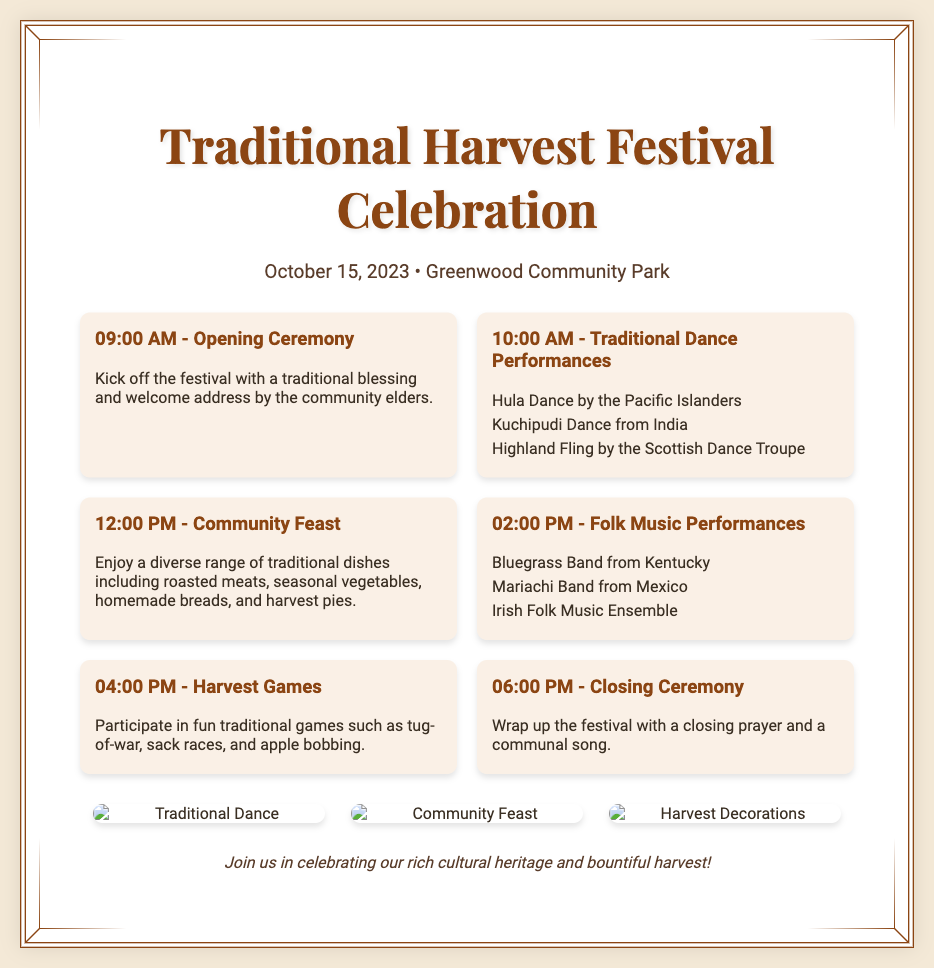What is the date of the festival? The date of the festival is mentioned in the document's date-location section, which states October 15, 2023.
Answer: October 15, 2023 What is the location of the celebration? The location is specified in the same section as the date, indicating Greenwood Community Park as the venue.
Answer: Greenwood Community Park What time does the opening ceremony start? The opening ceremony is scheduled for 09:00 AM according to the schedule of events listed in the document.
Answer: 09:00 AM How many traditional dances are performed? The schedule lists three traditional dance performances during the event, including Hula, Kuchipudi, and Highland Fling.
Answer: Three What type of food is served at the community feast? The document describes the community feast as having a diverse range of traditional dishes, explicitly mentioning roasted meats and seasonal vegetables.
Answer: Roasted meats and seasonal vegetables What is the last event of the festival? The final event is indicated in the schedule as the Closing Ceremony at 06:00 PM, wrapping up the festival activities.
Answer: Closing Ceremony What types of music are performed at the festival? The schedule includes performances by a Bluegrass Band, a Mariachi Band, and an Irish Folk Music Ensemble, showcasing a variety of musical traditions.
Answer: Bluegrass, Mariachi, Irish Folk What traditional games can participants enjoy? The document outlines that participants can engage in traditional games like tug-of-war, sack races, and apple bobbing during the Harvest Games.
Answer: Tug-of-war, sack races, apple bobbing 